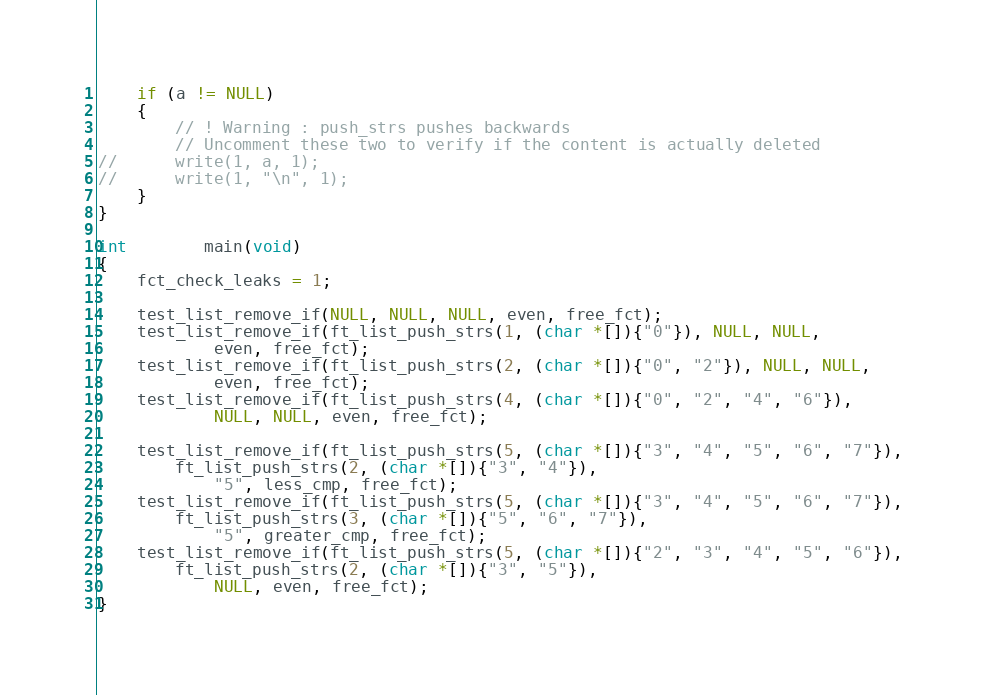Convert code to text. <code><loc_0><loc_0><loc_500><loc_500><_C_>	if (a != NULL)
	{
		// ! Warning : push_strs pushes backwards
		// Uncomment these two to verify if the content is actually deleted
//		write(1, a, 1);
//		write(1, "\n", 1);
	}
}

int		main(void)
{
	fct_check_leaks = 1;

	test_list_remove_if(NULL, NULL, NULL, even, free_fct);
	test_list_remove_if(ft_list_push_strs(1, (char *[]){"0"}), NULL, NULL,
			even, free_fct);
	test_list_remove_if(ft_list_push_strs(2, (char *[]){"0", "2"}), NULL, NULL,
			even, free_fct);
	test_list_remove_if(ft_list_push_strs(4, (char *[]){"0", "2", "4", "6"}),
			NULL, NULL, even, free_fct);

	test_list_remove_if(ft_list_push_strs(5, (char *[]){"3", "4", "5", "6", "7"}),
		ft_list_push_strs(2, (char *[]){"3", "4"}),
			"5", less_cmp, free_fct);
	test_list_remove_if(ft_list_push_strs(5, (char *[]){"3", "4", "5", "6", "7"}),
		ft_list_push_strs(3, (char *[]){"5", "6", "7"}),
			"5", greater_cmp, free_fct);
	test_list_remove_if(ft_list_push_strs(5, (char *[]){"2", "3", "4", "5", "6"}),
		ft_list_push_strs(2, (char *[]){"3", "5"}),
			NULL, even, free_fct);
}
</code> 